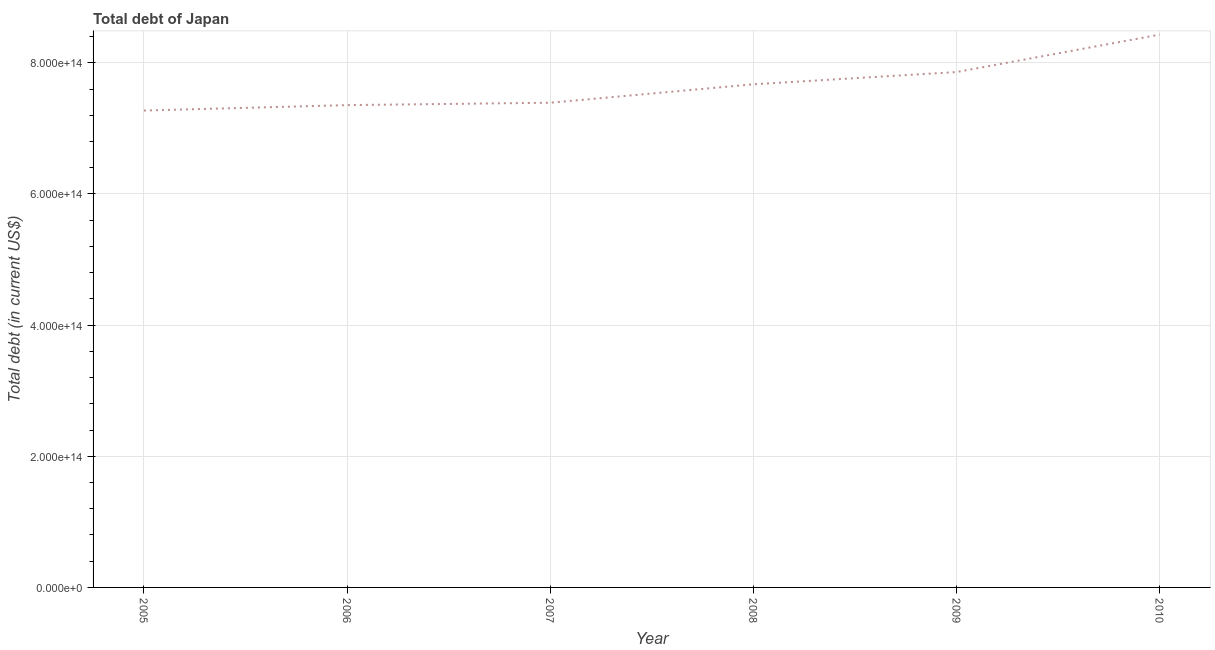What is the total debt in 2007?
Provide a succinct answer. 7.39e+14. Across all years, what is the maximum total debt?
Give a very brief answer. 8.43e+14. Across all years, what is the minimum total debt?
Keep it short and to the point. 7.27e+14. What is the sum of the total debt?
Keep it short and to the point. 4.60e+15. What is the difference between the total debt in 2007 and 2009?
Your answer should be compact. -4.68e+13. What is the average total debt per year?
Offer a very short reply. 7.66e+14. What is the median total debt?
Make the answer very short. 7.53e+14. Do a majority of the years between 2006 and 2005 (inclusive) have total debt greater than 800000000000000 US$?
Give a very brief answer. No. What is the ratio of the total debt in 2006 to that in 2009?
Offer a very short reply. 0.94. What is the difference between the highest and the second highest total debt?
Offer a very short reply. 5.71e+13. What is the difference between the highest and the lowest total debt?
Make the answer very short. 1.16e+14. How many years are there in the graph?
Your response must be concise. 6. What is the difference between two consecutive major ticks on the Y-axis?
Ensure brevity in your answer.  2.00e+14. Does the graph contain any zero values?
Keep it short and to the point. No. Does the graph contain grids?
Give a very brief answer. Yes. What is the title of the graph?
Your answer should be compact. Total debt of Japan. What is the label or title of the Y-axis?
Your answer should be very brief. Total debt (in current US$). What is the Total debt (in current US$) of 2005?
Make the answer very short. 7.27e+14. What is the Total debt (in current US$) in 2006?
Your answer should be compact. 7.35e+14. What is the Total debt (in current US$) in 2007?
Your answer should be compact. 7.39e+14. What is the Total debt (in current US$) in 2008?
Your response must be concise. 7.67e+14. What is the Total debt (in current US$) in 2009?
Provide a short and direct response. 7.86e+14. What is the Total debt (in current US$) in 2010?
Offer a terse response. 8.43e+14. What is the difference between the Total debt (in current US$) in 2005 and 2006?
Ensure brevity in your answer.  -8.27e+12. What is the difference between the Total debt (in current US$) in 2005 and 2007?
Provide a short and direct response. -1.19e+13. What is the difference between the Total debt (in current US$) in 2005 and 2008?
Your answer should be compact. -4.00e+13. What is the difference between the Total debt (in current US$) in 2005 and 2009?
Provide a short and direct response. -5.87e+13. What is the difference between the Total debt (in current US$) in 2005 and 2010?
Offer a terse response. -1.16e+14. What is the difference between the Total debt (in current US$) in 2006 and 2007?
Provide a short and direct response. -3.65e+12. What is the difference between the Total debt (in current US$) in 2006 and 2008?
Keep it short and to the point. -3.18e+13. What is the difference between the Total debt (in current US$) in 2006 and 2009?
Ensure brevity in your answer.  -5.05e+13. What is the difference between the Total debt (in current US$) in 2006 and 2010?
Ensure brevity in your answer.  -1.08e+14. What is the difference between the Total debt (in current US$) in 2007 and 2008?
Your answer should be compact. -2.81e+13. What is the difference between the Total debt (in current US$) in 2007 and 2009?
Your answer should be compact. -4.68e+13. What is the difference between the Total debt (in current US$) in 2007 and 2010?
Give a very brief answer. -1.04e+14. What is the difference between the Total debt (in current US$) in 2008 and 2009?
Offer a very short reply. -1.87e+13. What is the difference between the Total debt (in current US$) in 2008 and 2010?
Provide a short and direct response. -7.57e+13. What is the difference between the Total debt (in current US$) in 2009 and 2010?
Ensure brevity in your answer.  -5.71e+13. What is the ratio of the Total debt (in current US$) in 2005 to that in 2006?
Offer a very short reply. 0.99. What is the ratio of the Total debt (in current US$) in 2005 to that in 2007?
Make the answer very short. 0.98. What is the ratio of the Total debt (in current US$) in 2005 to that in 2008?
Provide a succinct answer. 0.95. What is the ratio of the Total debt (in current US$) in 2005 to that in 2009?
Your answer should be very brief. 0.93. What is the ratio of the Total debt (in current US$) in 2005 to that in 2010?
Your answer should be very brief. 0.86. What is the ratio of the Total debt (in current US$) in 2006 to that in 2009?
Keep it short and to the point. 0.94. What is the ratio of the Total debt (in current US$) in 2006 to that in 2010?
Give a very brief answer. 0.87. What is the ratio of the Total debt (in current US$) in 2007 to that in 2008?
Provide a short and direct response. 0.96. What is the ratio of the Total debt (in current US$) in 2007 to that in 2010?
Your answer should be very brief. 0.88. What is the ratio of the Total debt (in current US$) in 2008 to that in 2010?
Provide a short and direct response. 0.91. What is the ratio of the Total debt (in current US$) in 2009 to that in 2010?
Your response must be concise. 0.93. 